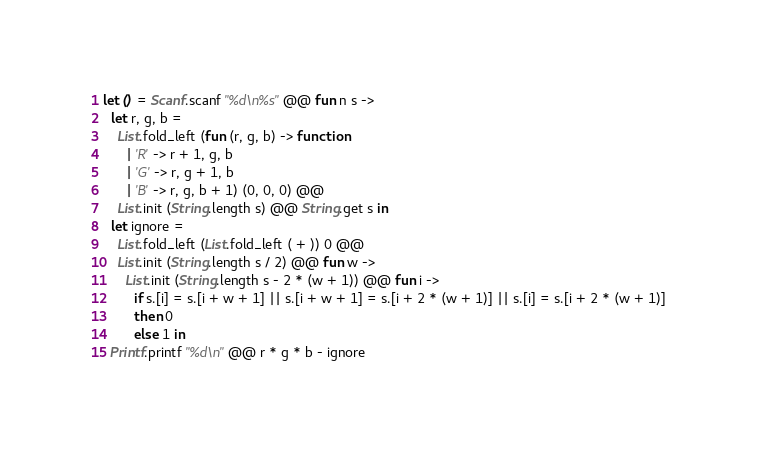<code> <loc_0><loc_0><loc_500><loc_500><_OCaml_>let () = Scanf.scanf "%d\n%s" @@ fun n s ->
  let r, g, b =
    List.fold_left (fun (r, g, b) -> function
      | 'R' -> r + 1, g, b
      | 'G' -> r, g + 1, b
      | 'B' -> r, g, b + 1) (0, 0, 0) @@
    List.init (String.length s) @@ String.get s in
  let ignore =
    List.fold_left (List.fold_left ( + )) 0 @@
    List.init (String.length s / 2) @@ fun w ->
      List.init (String.length s - 2 * (w + 1)) @@ fun i ->
        if s.[i] = s.[i + w + 1] || s.[i + w + 1] = s.[i + 2 * (w + 1)] || s.[i] = s.[i + 2 * (w + 1)]
        then 0
        else 1 in
  Printf.printf "%d\n" @@ r * g * b - ignore</code> 